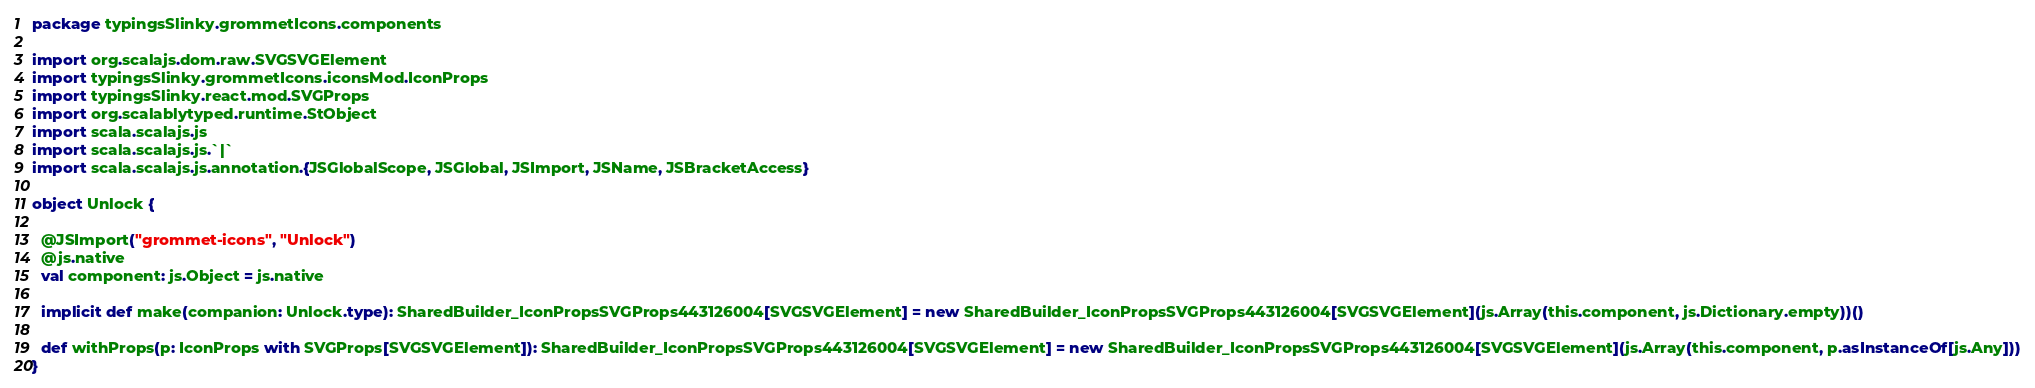Convert code to text. <code><loc_0><loc_0><loc_500><loc_500><_Scala_>package typingsSlinky.grommetIcons.components

import org.scalajs.dom.raw.SVGSVGElement
import typingsSlinky.grommetIcons.iconsMod.IconProps
import typingsSlinky.react.mod.SVGProps
import org.scalablytyped.runtime.StObject
import scala.scalajs.js
import scala.scalajs.js.`|`
import scala.scalajs.js.annotation.{JSGlobalScope, JSGlobal, JSImport, JSName, JSBracketAccess}

object Unlock {
  
  @JSImport("grommet-icons", "Unlock")
  @js.native
  val component: js.Object = js.native
  
  implicit def make(companion: Unlock.type): SharedBuilder_IconPropsSVGProps443126004[SVGSVGElement] = new SharedBuilder_IconPropsSVGProps443126004[SVGSVGElement](js.Array(this.component, js.Dictionary.empty))()
  
  def withProps(p: IconProps with SVGProps[SVGSVGElement]): SharedBuilder_IconPropsSVGProps443126004[SVGSVGElement] = new SharedBuilder_IconPropsSVGProps443126004[SVGSVGElement](js.Array(this.component, p.asInstanceOf[js.Any]))
}
</code> 